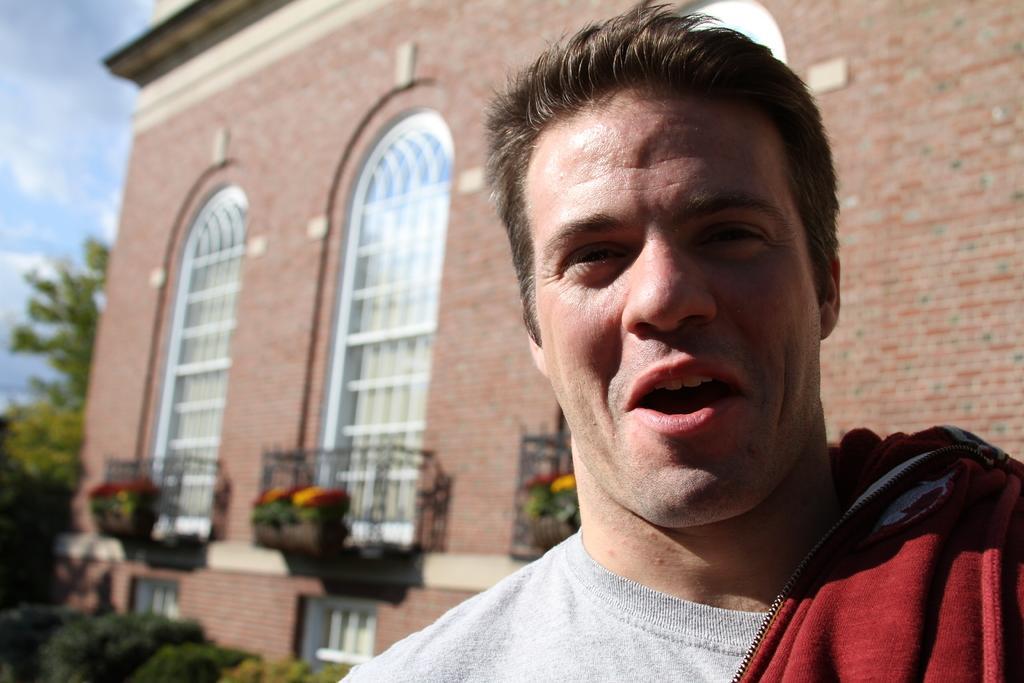How would you summarize this image in a sentence or two? In this image there is a man in the front smiling. In the background there is a building and the sky is cloudy and there are trees and plants. 